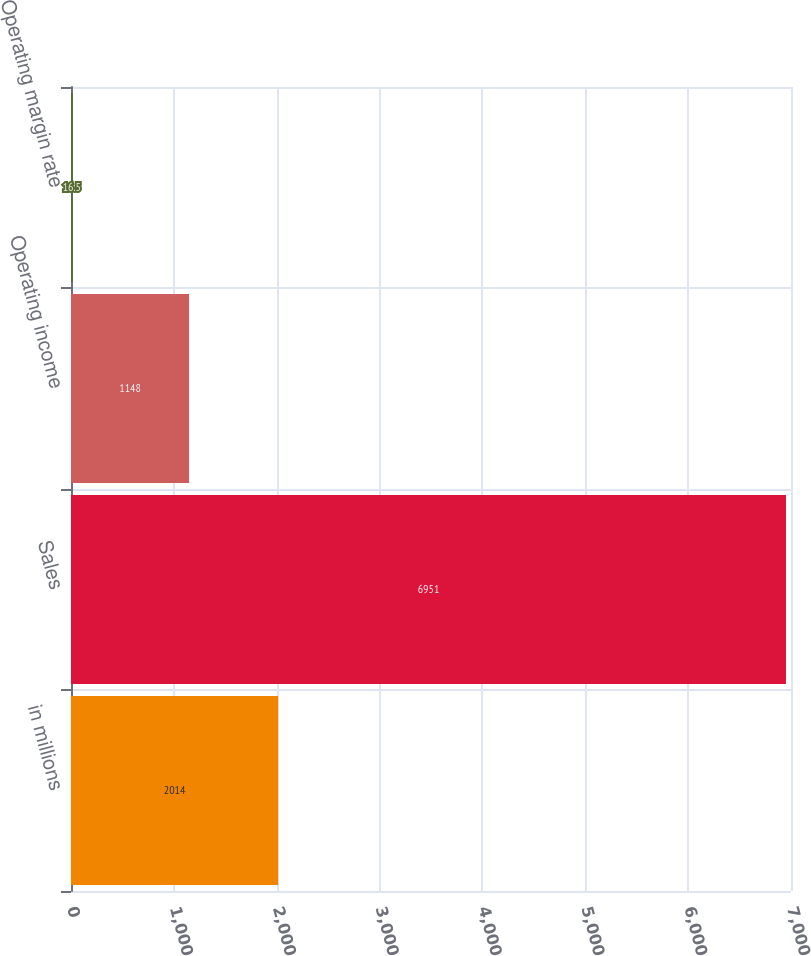<chart> <loc_0><loc_0><loc_500><loc_500><bar_chart><fcel>in millions<fcel>Sales<fcel>Operating income<fcel>Operating margin rate<nl><fcel>2014<fcel>6951<fcel>1148<fcel>16.5<nl></chart> 